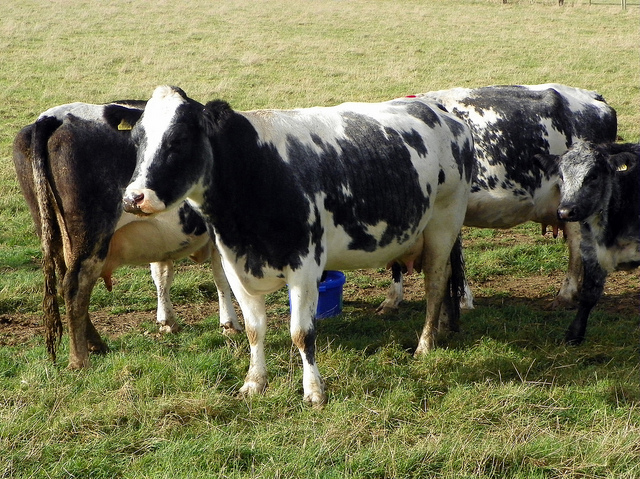What time of day does it seem to be in the image? Considering the shadows under the cows and the quality of the light, it appears to be either late morning or early afternoon, as the sun is not directly overhead but still provides a bright daylight. 